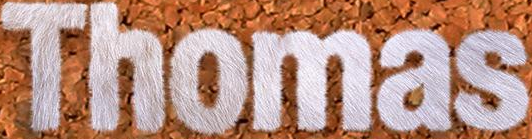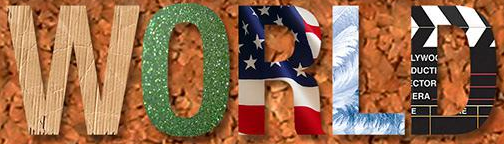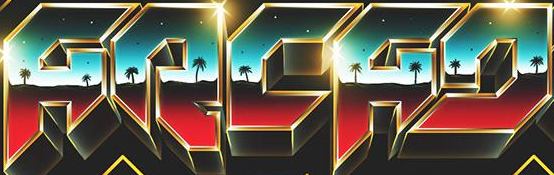Transcribe the words shown in these images in order, separated by a semicolon. Thomas; WORLD; ARCAD 